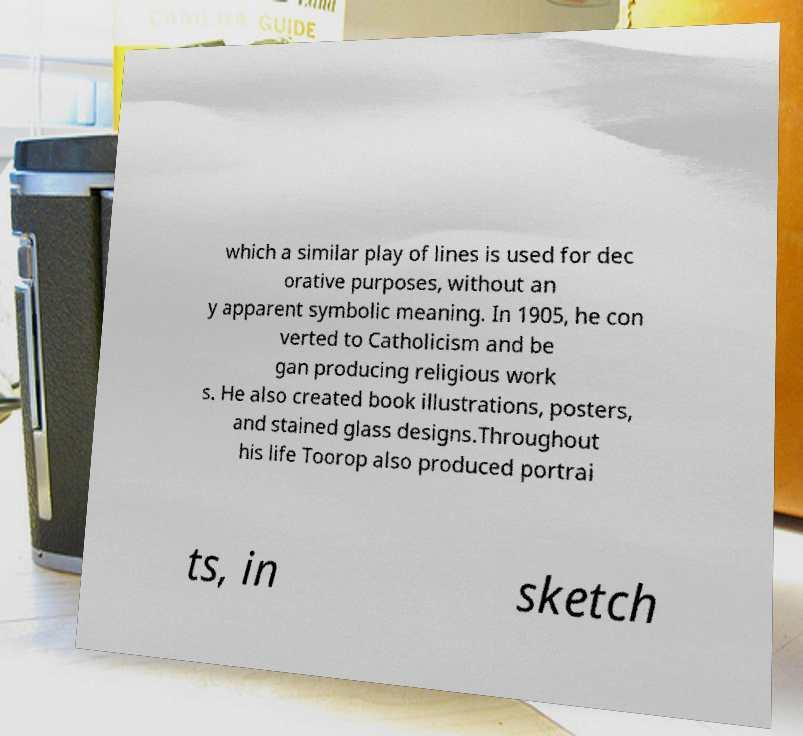Please read and relay the text visible in this image. What does it say? which a similar play of lines is used for dec orative purposes, without an y apparent symbolic meaning. In 1905, he con verted to Catholicism and be gan producing religious work s. He also created book illustrations, posters, and stained glass designs.Throughout his life Toorop also produced portrai ts, in sketch 